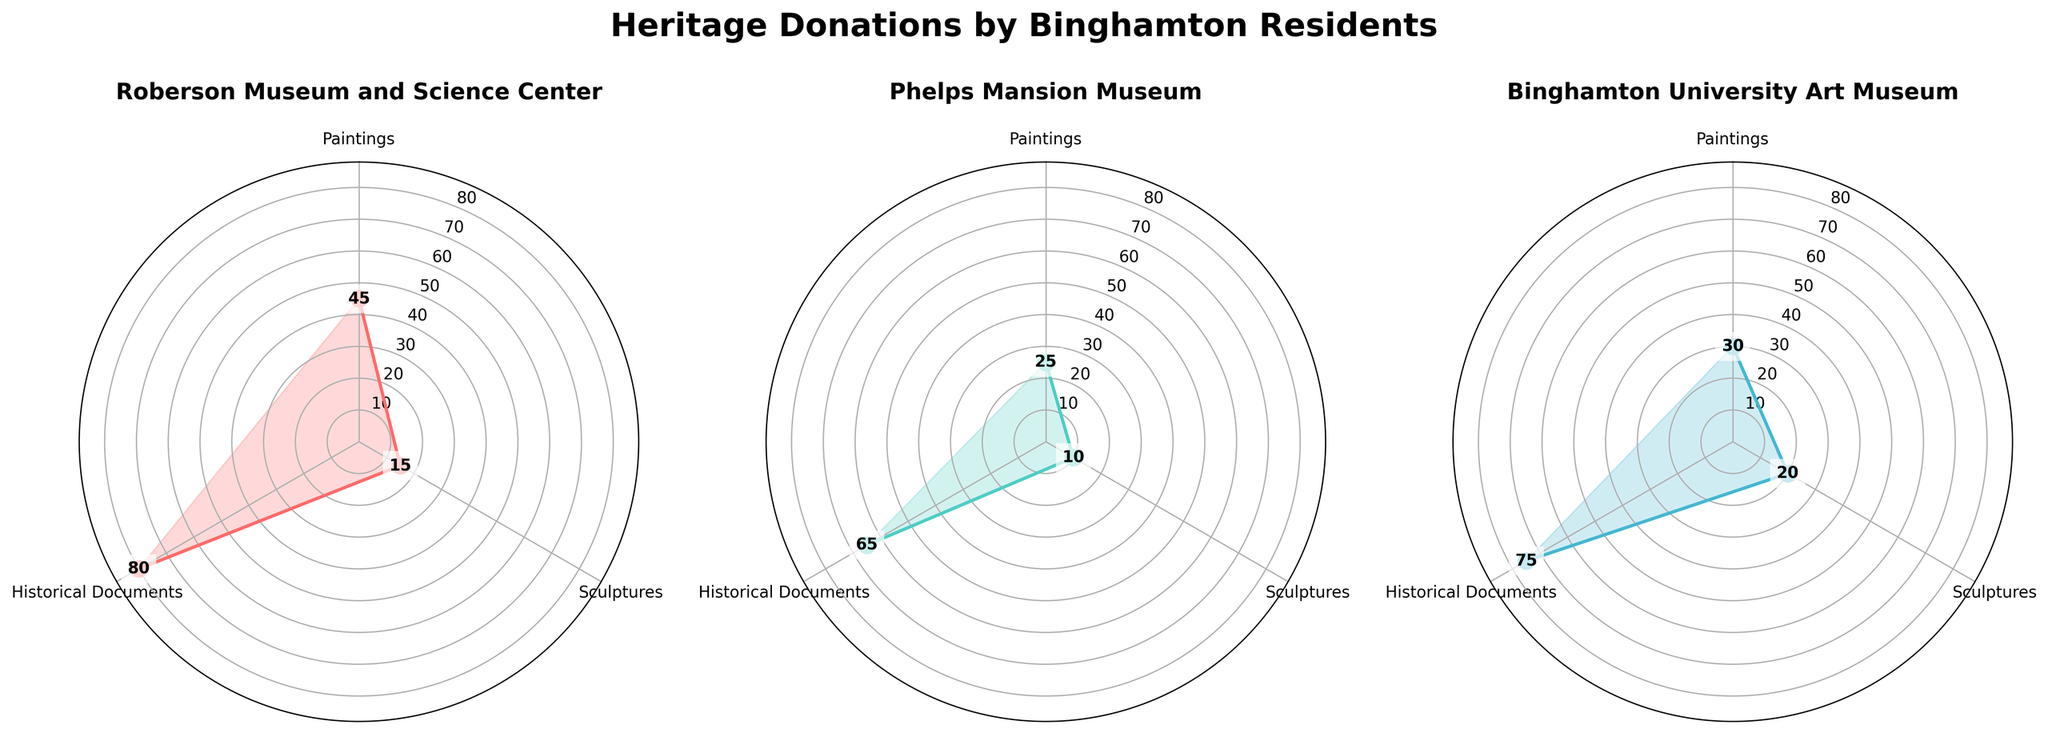What is the title of the figure? The title is prominently displayed at the top of the figure. By reading it, you can see that it is "Heritage Donations by Binghamton Residents".
Answer: Heritage Donations by Binghamton Residents Which institution has the highest quantity of donated Historical Documents? By looking at the labels and quantities in the figure, identify the institution with the largest bar segment for Historical Documents, which is colored distinctly.
Answer: Roberson Museum and Science Center How many paintings in total have been donated to the Phelps Mansion Museum? Sum the quantities of paintings for Phelps Mansion Museum. In the figure, find the corresponding institution's plot and read the values for the paintings. Calculation: 25 paintings.
Answer: 25 Which artifact type has the smallest quantity of donations for Binghamton University Art Museum? Look at the Binghamton University Art Museum subplot and identify the smallest value among the given artifact types. Here, the smallest quantity is for Sculptures.
Answer: Sculptures Between the Roberson Museum and Science Center and the Binghamton University Art Museum, which one received more sculptures? Compare the quantities of sculptures in the Roberson Museum and Science Center subplot and the Binghamton University Art Museum subplot. Roberson has 15 and Binghamton University has 20.
Answer: Binghamton University Art Museum How many more paintings were donated to Roberson Museum and Science Center compared to the Binghamton University Art Museum? Subtract the quantity of paintings in Binghamton University Art Museum from the quantity in Roberson Museum and Science Center. 45 (Roberson) - 30 (Binghamton) = 15.
Answer: 15 What is the average quantity of donated Historical Documents across all institutions? Sum the quantities of donated Historical Documents from all subplots and divide by the number of institutions. Sum: 80 (Roberson) + 65 (Phelps) + 75 (Binghamton) = 220. Average: 220 / 3 ≈ 73.33.
Answer: 73.33 Which type of artifact has the most donations overall? Sum the donations for each artifact type across all institutions and compare the totals. Historical Documents: 80 + 65 + 75 = 220, Paintings: 45 + 25 + 30 = 100, Sculptures: 15 + 10 + 20 = 45. Historical Documents have the most donations.
Answer: Historical Documents What are the colors used for the institutions in the figure? Identify the different colors used in the plots for each institution. Observing the figure, you can distinguish the colors used.
Answer: Red, Teal, Blue 